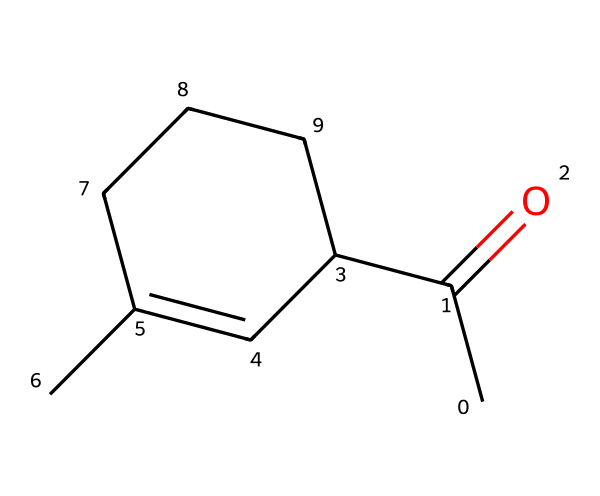What is the functional group present in jasmone? The functional group is determined by the presence of the carbonyl (C=O) group in the structure, which is indicative of ketones.
Answer: ketone How many carbon atoms are in jasmone? By counting the carbon atoms in the structure (C atoms are represented in the SMILES), there are 10 distinct carbon atoms present.
Answer: 10 What is the degree of unsaturation in jasmone? The degree of unsaturation can be calculated using the formula: (2C + 2 - H - X)/2. For jasmone, C=10, H=14, and there are no halogens (X=0), resulting in (2*10 + 2 - 14)/2 = 4, indicating 4 degrees of unsaturation.
Answer: 4 Is jasmone more similar to aldehydes or to ketones? Jasmone has a carbonyl functional group flanked by two carbon chains, typical of ketones, rather than an aldehyde which would have a carbonyl at the end of the carbon chain.
Answer: ketones What type of isomerism is exhibited by jasmone in relation to the position of the double bonds? The positioning of double bonds in jasmone can lead to geometric isomerism, particularly due to the cyclic nature of part of its structure, which allows for cis/trans variations.
Answer: geometric isomerism What physical property is associated with jasmone's structure? Due to the presence of the ketone functional group and the lack of significant branching, jasmone is likely to have a pleasant, floral aroma, characteristic of many fragrant compounds.
Answer: aroma 